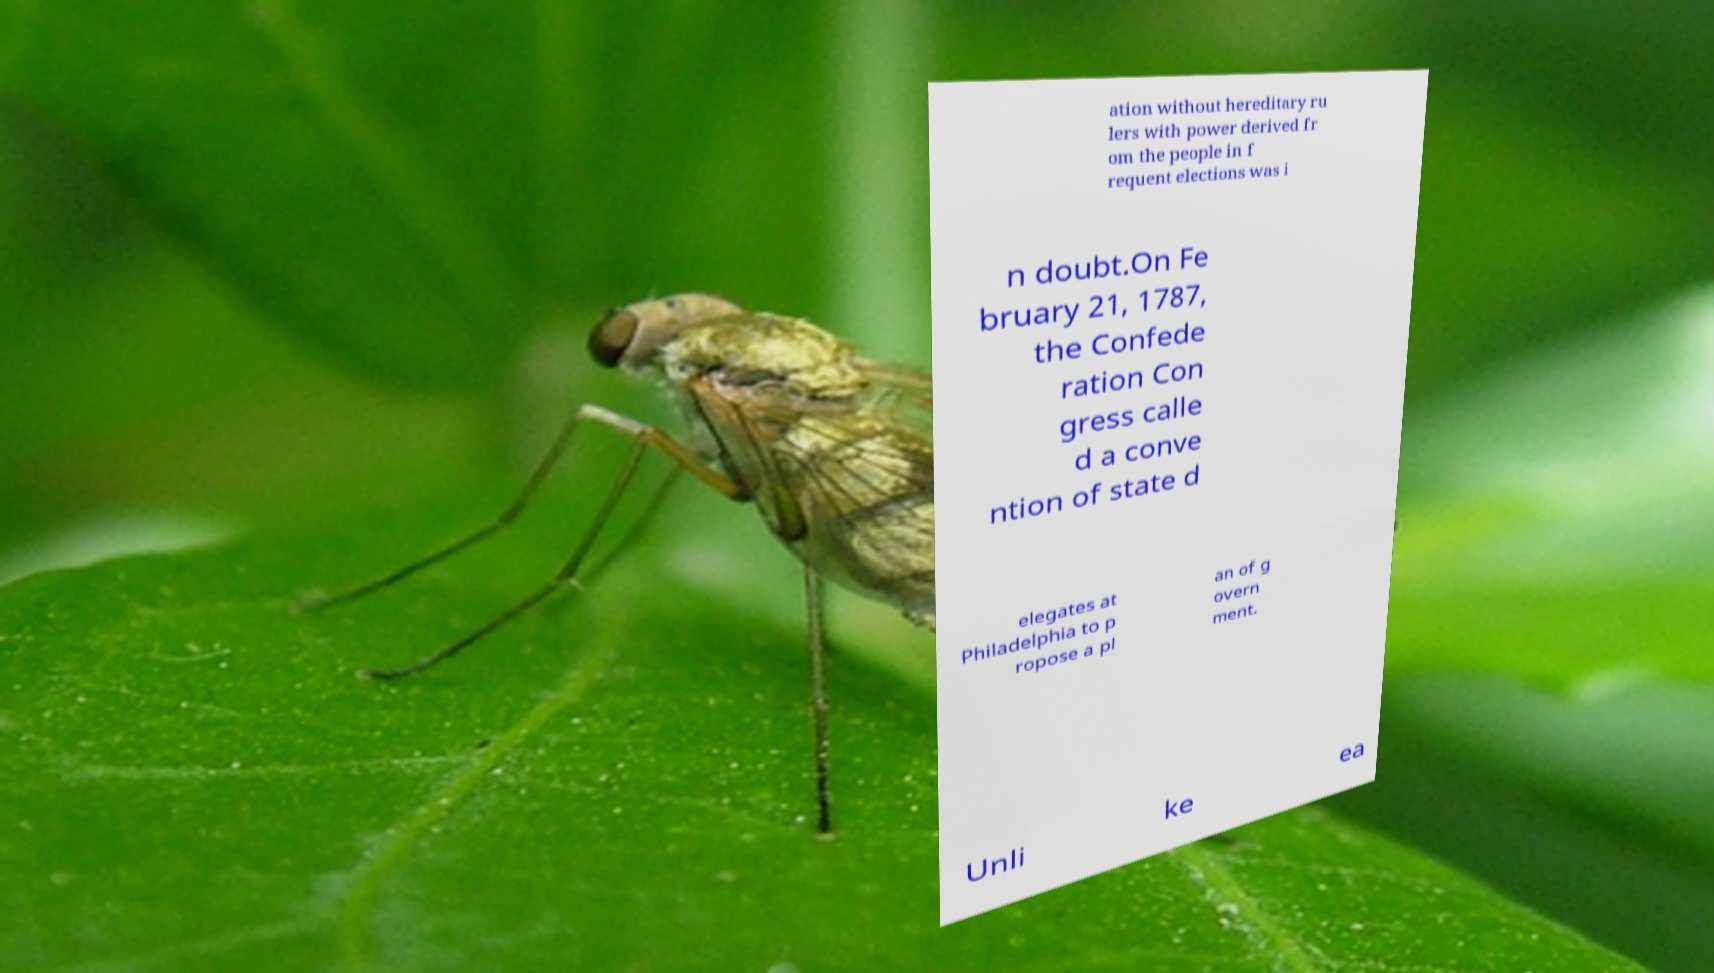For documentation purposes, I need the text within this image transcribed. Could you provide that? ation without hereditary ru lers with power derived fr om the people in f requent elections was i n doubt.On Fe bruary 21, 1787, the Confede ration Con gress calle d a conve ntion of state d elegates at Philadelphia to p ropose a pl an of g overn ment. Unli ke ea 